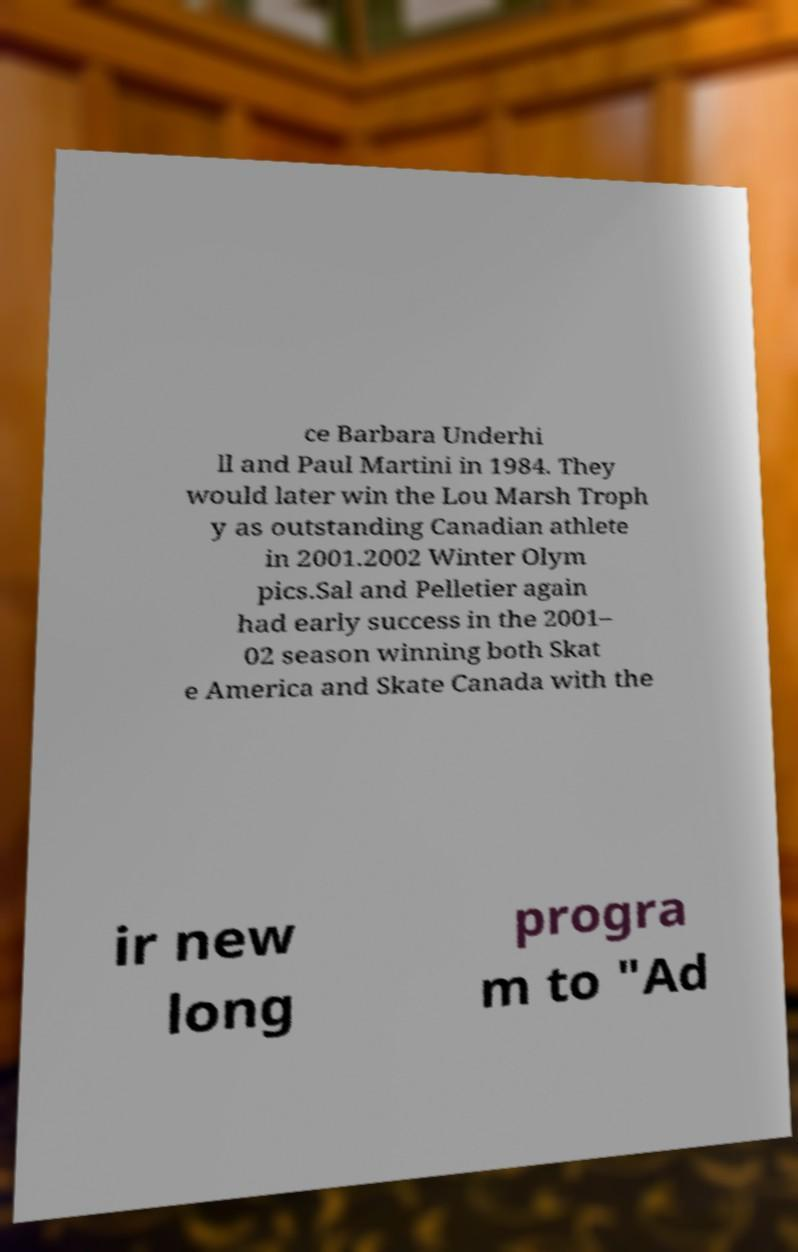Could you extract and type out the text from this image? ce Barbara Underhi ll and Paul Martini in 1984. They would later win the Lou Marsh Troph y as outstanding Canadian athlete in 2001.2002 Winter Olym pics.Sal and Pelletier again had early success in the 2001– 02 season winning both Skat e America and Skate Canada with the ir new long progra m to "Ad 